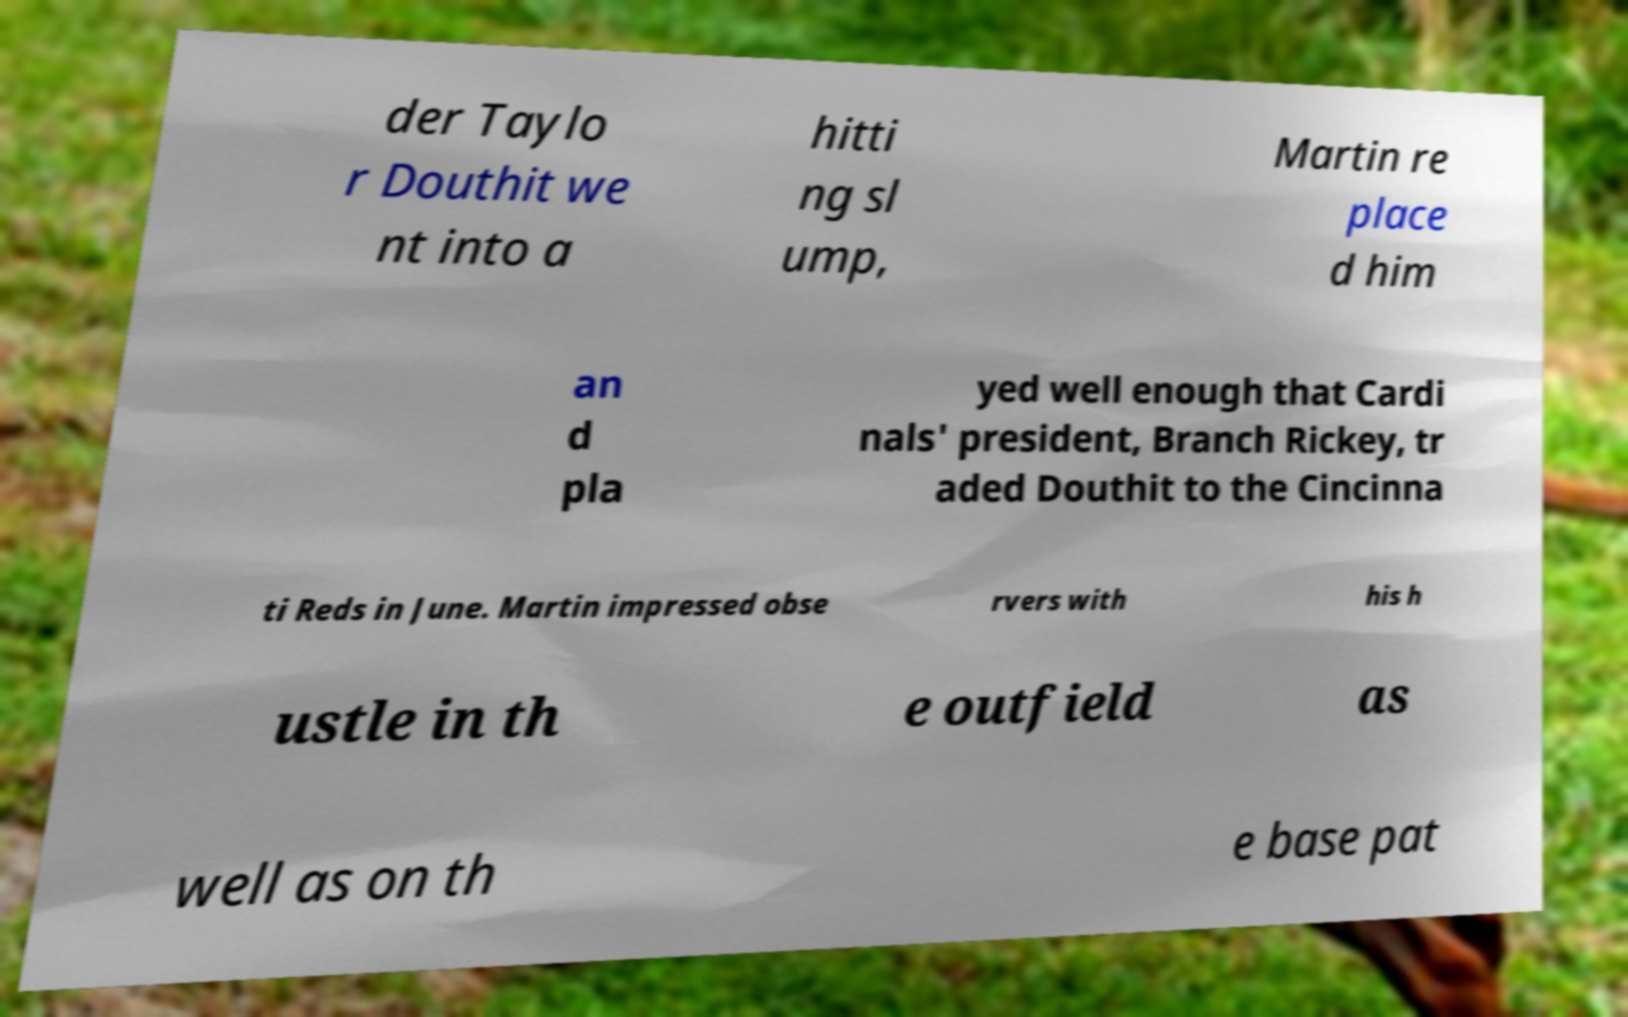Can you accurately transcribe the text from the provided image for me? der Taylo r Douthit we nt into a hitti ng sl ump, Martin re place d him an d pla yed well enough that Cardi nals' president, Branch Rickey, tr aded Douthit to the Cincinna ti Reds in June. Martin impressed obse rvers with his h ustle in th e outfield as well as on th e base pat 